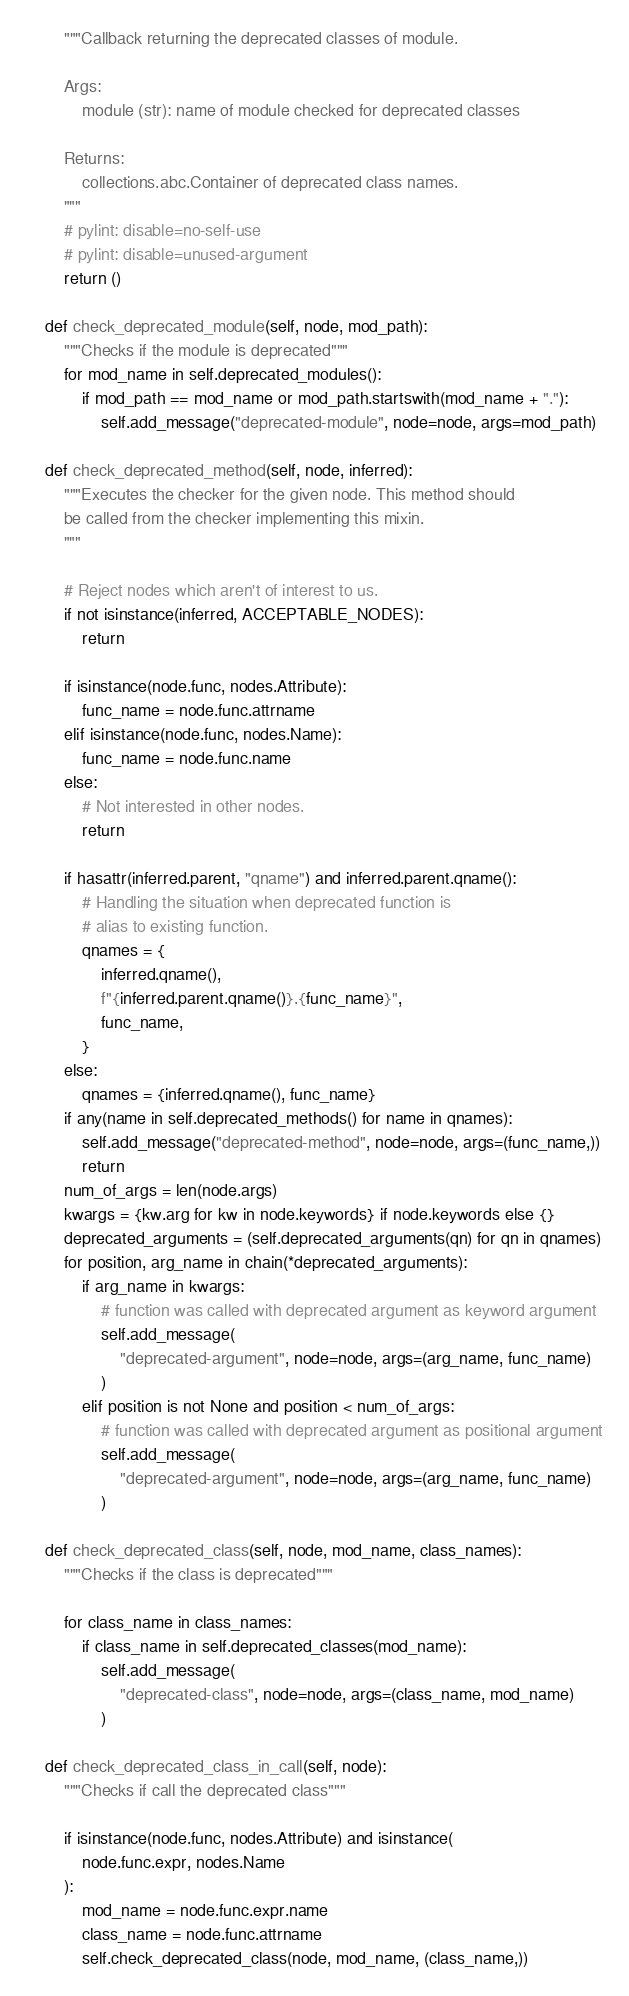Convert code to text. <code><loc_0><loc_0><loc_500><loc_500><_Python_>        """Callback returning the deprecated classes of module.

        Args:
            module (str): name of module checked for deprecated classes

        Returns:
            collections.abc.Container of deprecated class names.
        """
        # pylint: disable=no-self-use
        # pylint: disable=unused-argument
        return ()

    def check_deprecated_module(self, node, mod_path):
        """Checks if the module is deprecated"""
        for mod_name in self.deprecated_modules():
            if mod_path == mod_name or mod_path.startswith(mod_name + "."):
                self.add_message("deprecated-module", node=node, args=mod_path)

    def check_deprecated_method(self, node, inferred):
        """Executes the checker for the given node. This method should
        be called from the checker implementing this mixin.
        """

        # Reject nodes which aren't of interest to us.
        if not isinstance(inferred, ACCEPTABLE_NODES):
            return

        if isinstance(node.func, nodes.Attribute):
            func_name = node.func.attrname
        elif isinstance(node.func, nodes.Name):
            func_name = node.func.name
        else:
            # Not interested in other nodes.
            return

        if hasattr(inferred.parent, "qname") and inferred.parent.qname():
            # Handling the situation when deprecated function is
            # alias to existing function.
            qnames = {
                inferred.qname(),
                f"{inferred.parent.qname()}.{func_name}",
                func_name,
            }
        else:
            qnames = {inferred.qname(), func_name}
        if any(name in self.deprecated_methods() for name in qnames):
            self.add_message("deprecated-method", node=node, args=(func_name,))
            return
        num_of_args = len(node.args)
        kwargs = {kw.arg for kw in node.keywords} if node.keywords else {}
        deprecated_arguments = (self.deprecated_arguments(qn) for qn in qnames)
        for position, arg_name in chain(*deprecated_arguments):
            if arg_name in kwargs:
                # function was called with deprecated argument as keyword argument
                self.add_message(
                    "deprecated-argument", node=node, args=(arg_name, func_name)
                )
            elif position is not None and position < num_of_args:
                # function was called with deprecated argument as positional argument
                self.add_message(
                    "deprecated-argument", node=node, args=(arg_name, func_name)
                )

    def check_deprecated_class(self, node, mod_name, class_names):
        """Checks if the class is deprecated"""

        for class_name in class_names:
            if class_name in self.deprecated_classes(mod_name):
                self.add_message(
                    "deprecated-class", node=node, args=(class_name, mod_name)
                )

    def check_deprecated_class_in_call(self, node):
        """Checks if call the deprecated class"""

        if isinstance(node.func, nodes.Attribute) and isinstance(
            node.func.expr, nodes.Name
        ):
            mod_name = node.func.expr.name
            class_name = node.func.attrname
            self.check_deprecated_class(node, mod_name, (class_name,))
</code> 